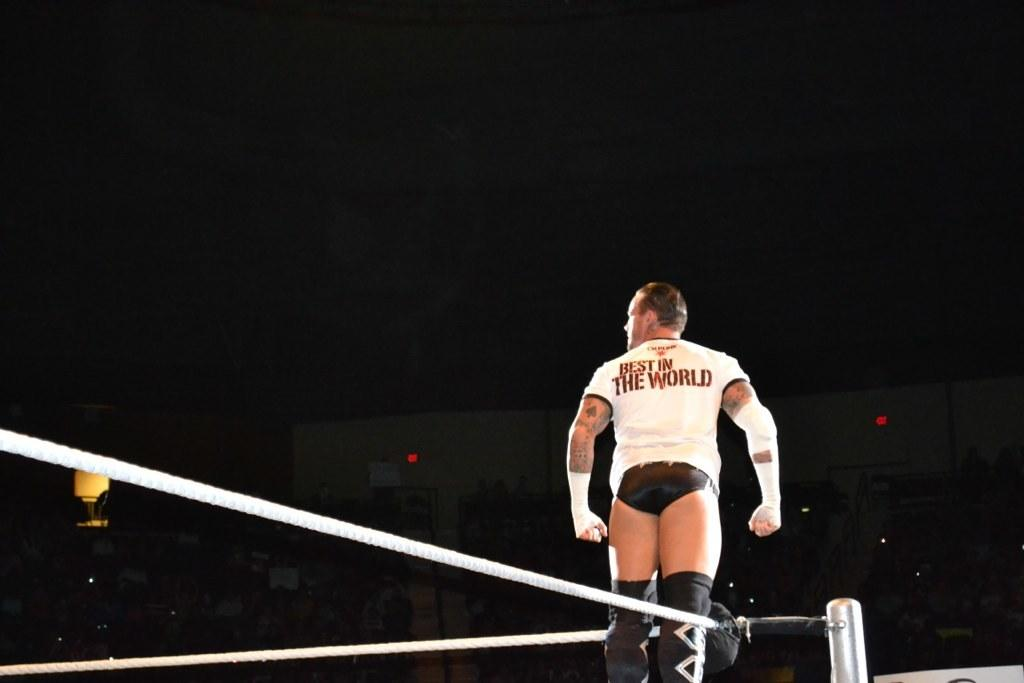Provide a one-sentence caption for the provided image. a wrestler with a shirt that says Best n the World on the back of it. 